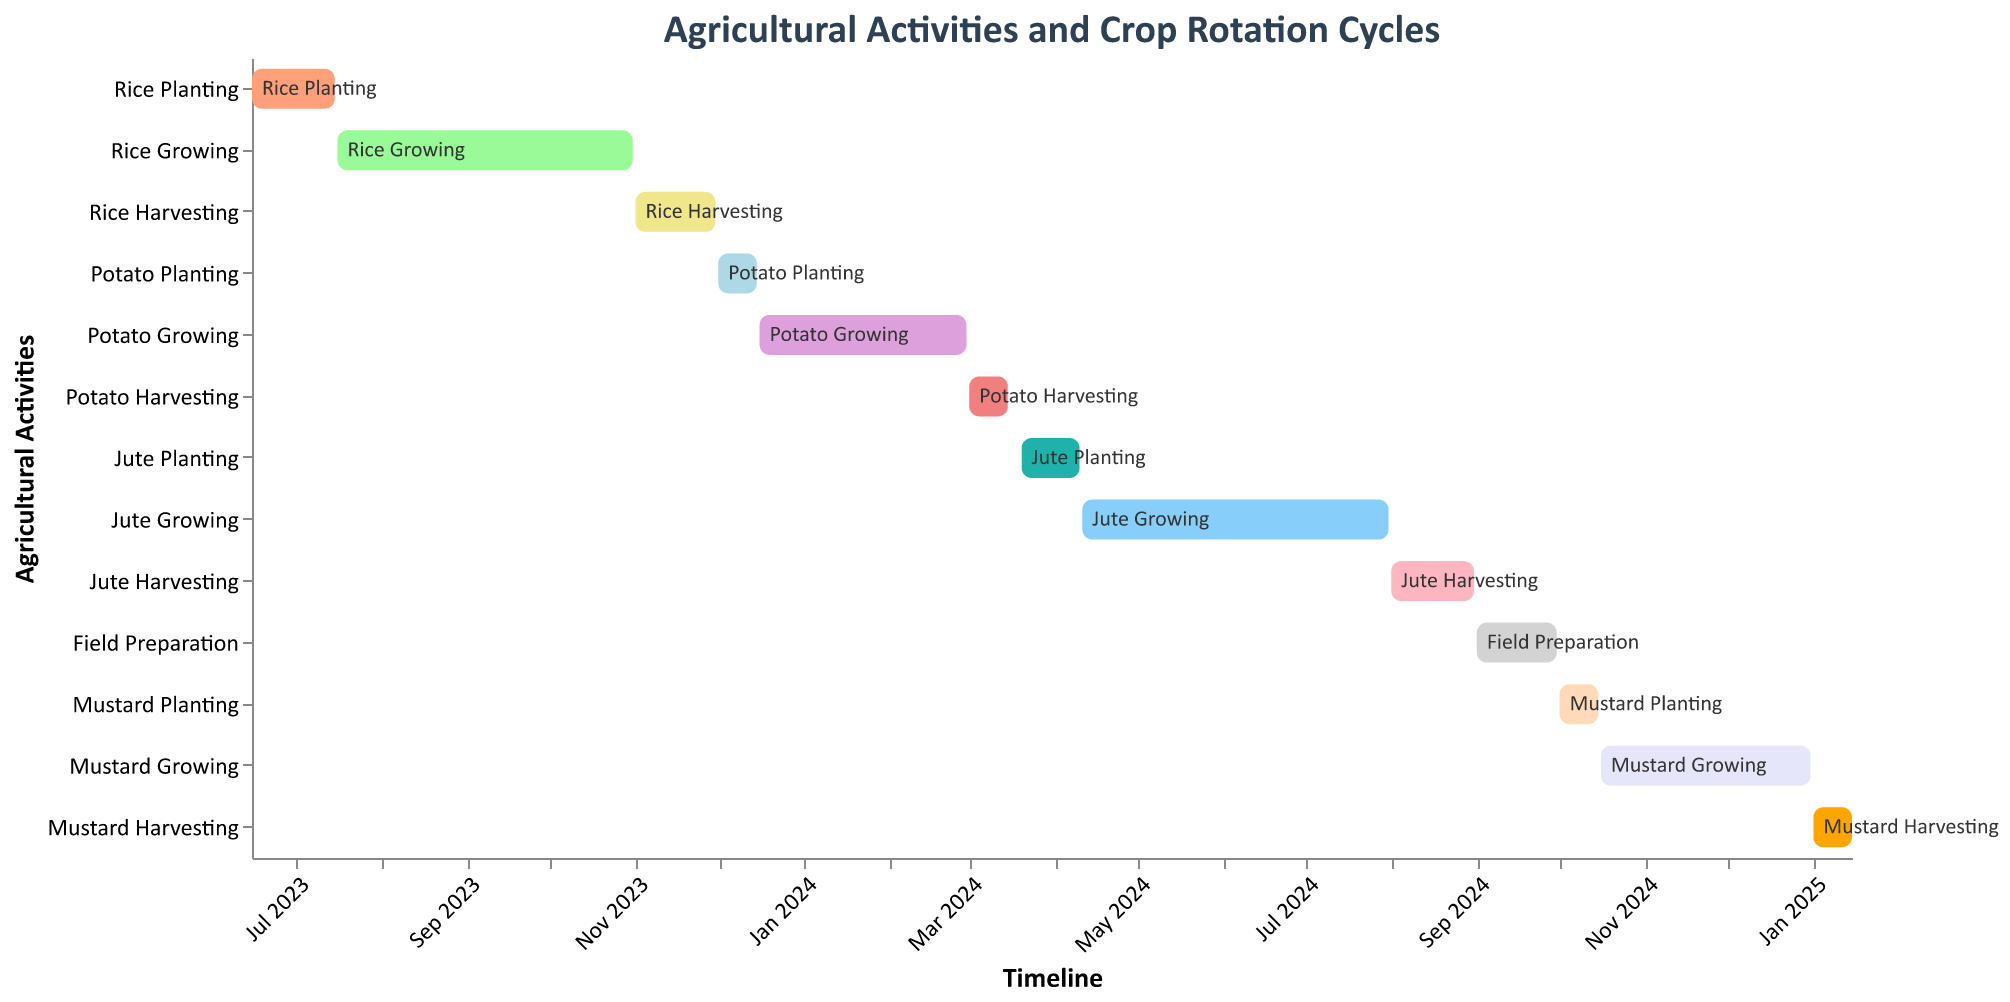What is the duration of Rice Harvesting? Rice Harvesting starts on November 1, 2023, and ends on November 30, 2023. The duration is the number of days between these two dates. November has 30 days, so the duration is 30 days.
Answer: 30 days When does Mustard Harvesting end? Mustard Harvesting starts on January 1, 2025, and as per the timeline, it ends on January 15, 2025.
Answer: January 15, 2025 Which task takes place directly after Rice Harvesting? According to the timeline, Rice Harvesting ends on November 30, 2023. The next task starting after this date is Potato Planting, which begins on December 1, 2023.
Answer: Potato Planting How long is the interval between the end of Potato Harvesting and the start of Jute Planting? Potato Harvesting ends on March 15, 2024, and Jute Planting starts on March 20, 2024. The interval between these dates is 5 days.
Answer: 5 days Which crop growing period is the longest? The task durations can be compared to find the longest growing period. Rice Growing (July 16 to October 31) lasts about 108 days, Potato Growing (December 16 to February 29) lasts about 76 days, Jute Growing (April 11 to July 31) lasts about 112 days, and Mustard Growing (October 16 to December 31) lasts about 76 days. Jute Growing is the longest.
Answer: Jute Growing How many tasks are scheduled in total? Each row represents a different task, and counting all unique tasks gives the total number. There are 13 tasks in total.
Answer: 13 tasks What is the sequence of tasks from September 2024 to January 2025? The Gantt chart's timeline for September 2024 to January 2025 includes Field Preparation (September 2024), Mustard Planting (October 2024), Mustard Growing (October 2024 to December 2024), and Mustard Harvesting (January 2025).
Answer: Field Preparation, Mustard Planting, Mustard Growing, Mustard Harvesting Which task has the shortest duration? By comparing the start and end dates of each task, Potato Planting (December 1 to December 15) and Mustard Planting (October 1 to October 15) both are the shortest, each lasting 15 days.
Answer: Potato Planting, Mustard Planting What tasks overlap with Jute Growing? Jute Growing is from April 11, 2024, to July 31, 2024. The tasks that overlap within this timeframe are Jute Planting (ends April 10, overlapped slightly), Jute Harvesting (starts August 1, not overlapping), and growing periods do overlap slightly as they might involve transition processes.
Answer: None 